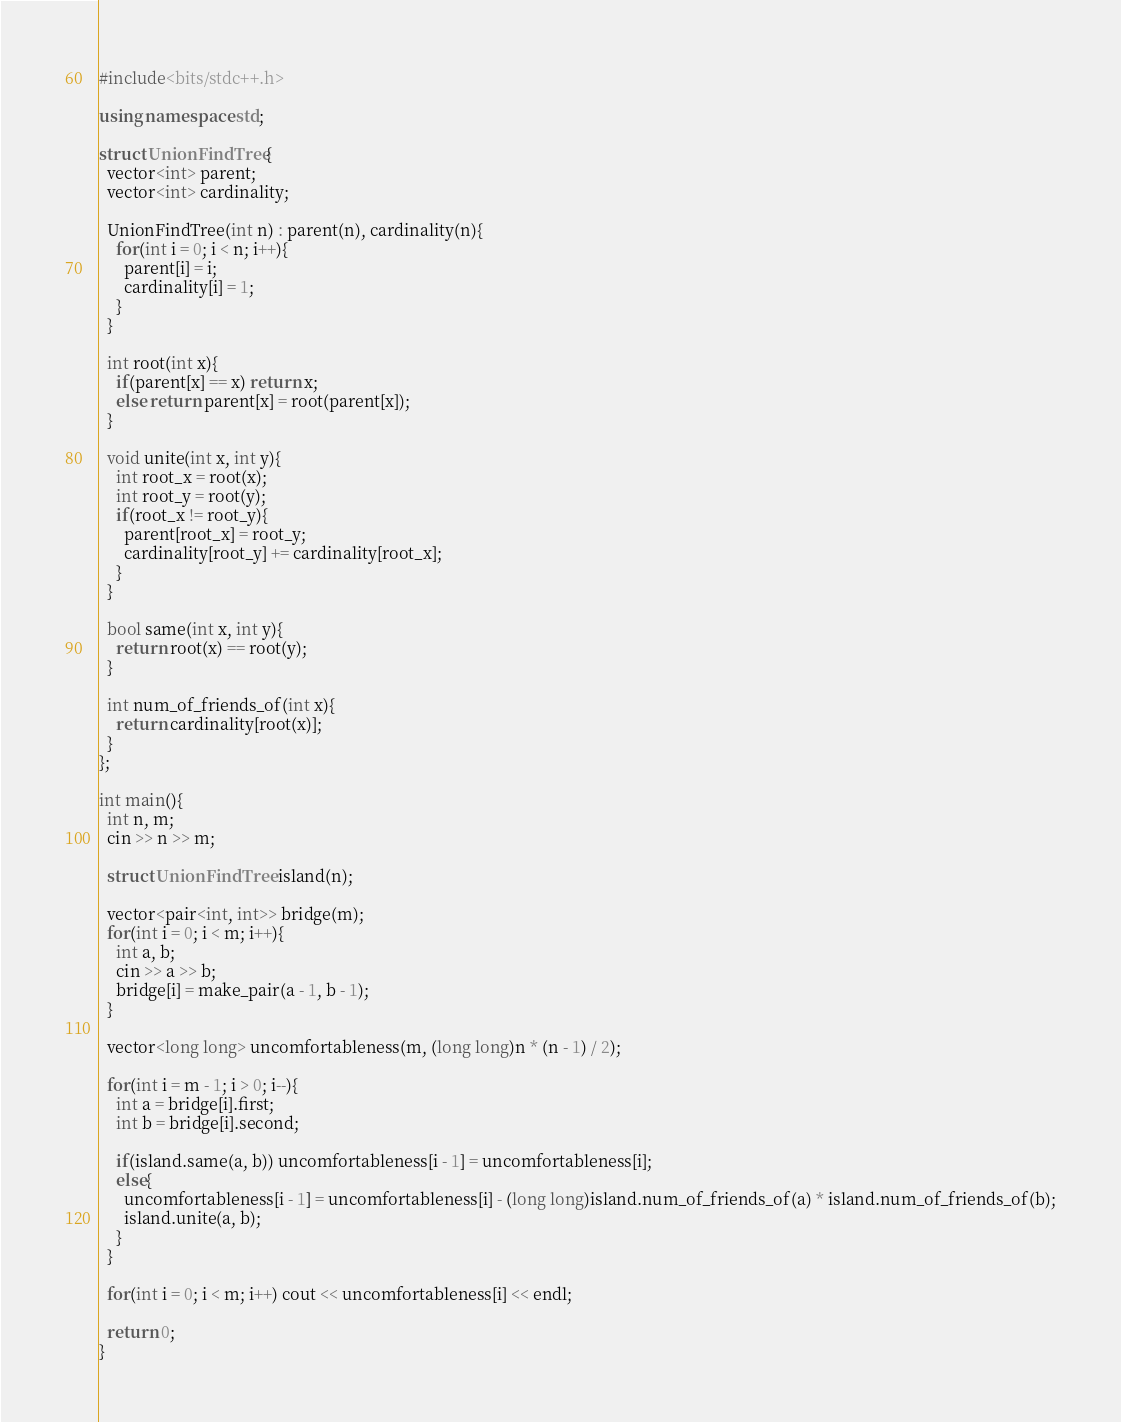<code> <loc_0><loc_0><loc_500><loc_500><_C++_>#include<bits/stdc++.h>

using namespace std;

struct UnionFindTree{
  vector<int> parent;
  vector<int> cardinality;
  
  UnionFindTree(int n) : parent(n), cardinality(n){
    for(int i = 0; i < n; i++){
      parent[i] = i;
      cardinality[i] = 1;
    }
  }
  
  int root(int x){
    if(parent[x] == x) return x;
    else return parent[x] = root(parent[x]);
  }
  
  void unite(int x, int y){
    int root_x = root(x);
    int root_y = root(y);
    if(root_x != root_y){
      parent[root_x] = root_y;
      cardinality[root_y] += cardinality[root_x];
    }
  }
  
  bool same(int x, int y){
    return root(x) == root(y);
  }
  
  int num_of_friends_of(int x){
    return cardinality[root(x)];
  }
};

int main(){
  int n, m;
  cin >> n >> m;
  
  struct UnionFindTree island(n);
  
  vector<pair<int, int>> bridge(m);
  for(int i = 0; i < m; i++){
    int a, b;
    cin >> a >> b;
    bridge[i] = make_pair(a - 1, b - 1);
  }
  
  vector<long long> uncomfortableness(m, (long long)n * (n - 1) / 2);
  
  for(int i = m - 1; i > 0; i--){
    int a = bridge[i].first;
    int b = bridge[i].second;
    
    if(island.same(a, b)) uncomfortableness[i - 1] = uncomfortableness[i];
    else{
      uncomfortableness[i - 1] = uncomfortableness[i] - (long long)island.num_of_friends_of(a) * island.num_of_friends_of(b);
      island.unite(a, b);
    }
  }
  
  for(int i = 0; i < m; i++) cout << uncomfortableness[i] << endl;
  
  return 0;
}</code> 